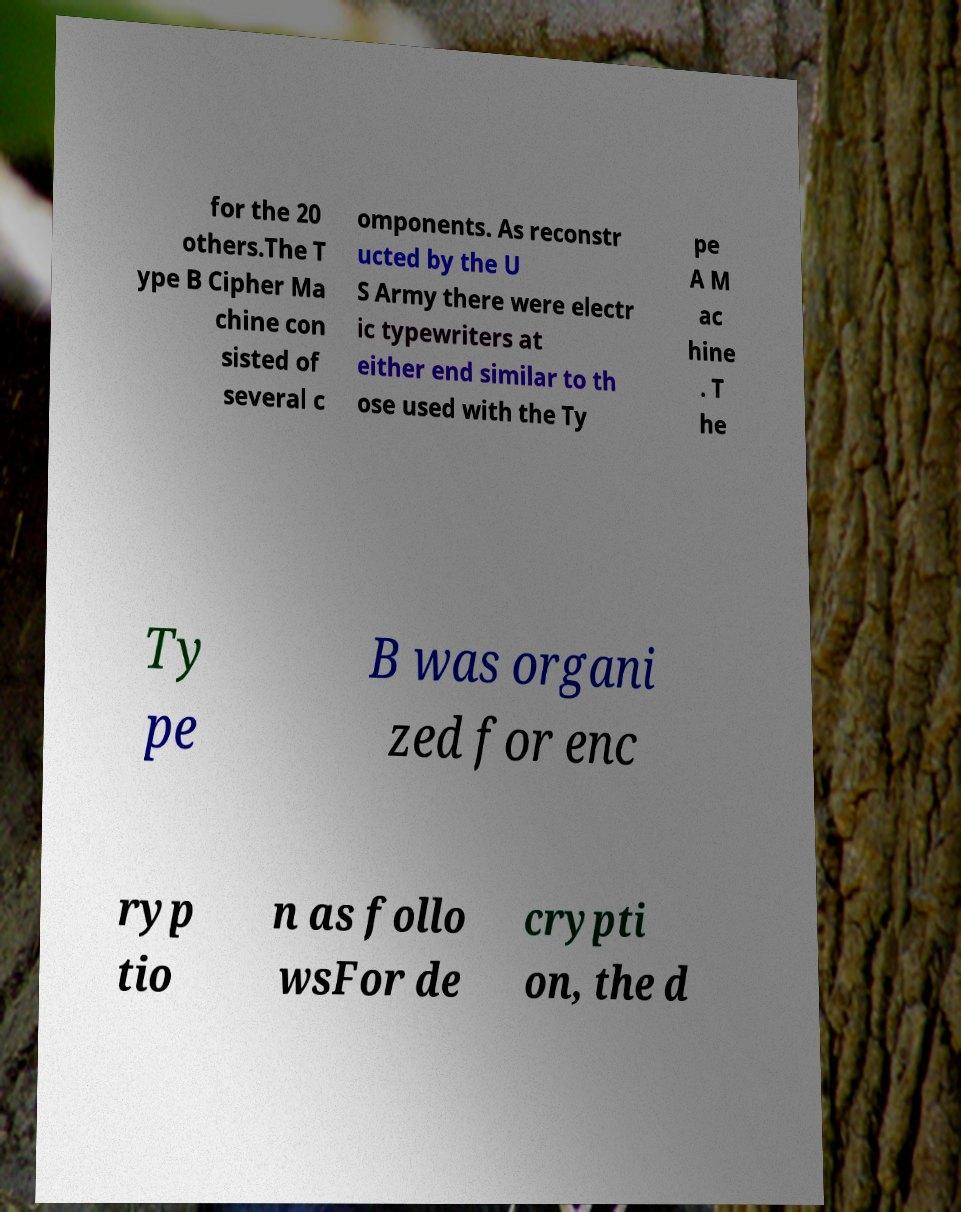There's text embedded in this image that I need extracted. Can you transcribe it verbatim? for the 20 others.The T ype B Cipher Ma chine con sisted of several c omponents. As reconstr ucted by the U S Army there were electr ic typewriters at either end similar to th ose used with the Ty pe A M ac hine . T he Ty pe B was organi zed for enc ryp tio n as follo wsFor de crypti on, the d 